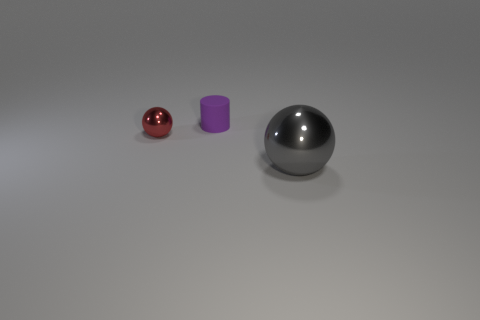Is there any other thing that is the same size as the gray metallic thing?
Make the answer very short. No. What material is the red object that is the same size as the purple matte cylinder?
Offer a terse response. Metal. Is there a red metallic ball of the same size as the purple thing?
Keep it short and to the point. Yes. What is the color of the object behind the small sphere?
Your answer should be very brief. Purple. There is a metallic thing that is to the right of the purple cylinder; is there a tiny red metallic thing left of it?
Ensure brevity in your answer.  Yes. What number of other things are there of the same color as the small rubber object?
Ensure brevity in your answer.  0. There is a sphere that is left of the small cylinder; is its size the same as the metal object that is right of the rubber thing?
Provide a succinct answer. No. There is a thing behind the metal thing that is on the left side of the gray object; what is its size?
Offer a very short reply. Small. The object that is in front of the purple rubber cylinder and to the right of the red shiny sphere is made of what material?
Offer a terse response. Metal. What color is the cylinder?
Offer a terse response. Purple. 